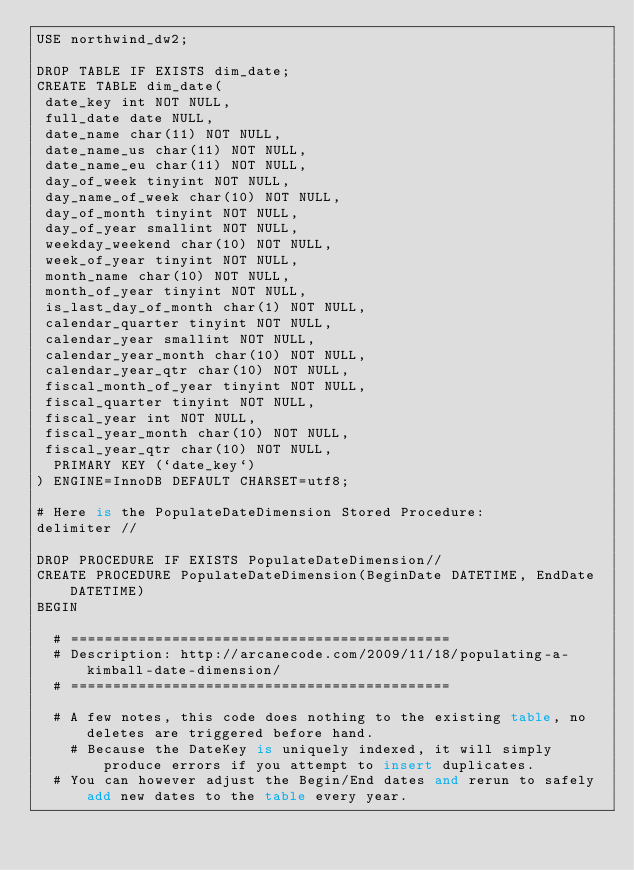Convert code to text. <code><loc_0><loc_0><loc_500><loc_500><_SQL_>USE northwind_dw2;

DROP TABLE IF EXISTS dim_date;
CREATE TABLE dim_date(
 date_key int NOT NULL,
 full_date date NULL,
 date_name char(11) NOT NULL,
 date_name_us char(11) NOT NULL,
 date_name_eu char(11) NOT NULL,
 day_of_week tinyint NOT NULL,
 day_name_of_week char(10) NOT NULL,
 day_of_month tinyint NOT NULL,
 day_of_year smallint NOT NULL,
 weekday_weekend char(10) NOT NULL,
 week_of_year tinyint NOT NULL,
 month_name char(10) NOT NULL,
 month_of_year tinyint NOT NULL,
 is_last_day_of_month char(1) NOT NULL,
 calendar_quarter tinyint NOT NULL,
 calendar_year smallint NOT NULL,
 calendar_year_month char(10) NOT NULL,
 calendar_year_qtr char(10) NOT NULL,
 fiscal_month_of_year tinyint NOT NULL,
 fiscal_quarter tinyint NOT NULL,
 fiscal_year int NOT NULL,
 fiscal_year_month char(10) NOT NULL,
 fiscal_year_qtr char(10) NOT NULL,
  PRIMARY KEY (`date_key`)
) ENGINE=InnoDB DEFAULT CHARSET=utf8;

# Here is the PopulateDateDimension Stored Procedure: 
delimiter //

DROP PROCEDURE IF EXISTS PopulateDateDimension//
CREATE PROCEDURE PopulateDateDimension(BeginDate DATETIME, EndDate DATETIME)
BEGIN

	# =============================================
	# Description: http://arcanecode.com/2009/11/18/populating-a-kimball-date-dimension/
	# =============================================

	# A few notes, this code does nothing to the existing table, no deletes are triggered before hand.
    # Because the DateKey is uniquely indexed, it will simply produce errors if you attempt to insert duplicates.
	# You can however adjust the Begin/End dates and rerun to safely add new dates to the table every year.</code> 